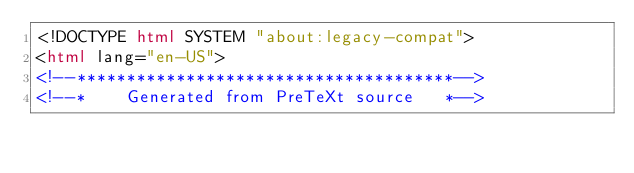<code> <loc_0><loc_0><loc_500><loc_500><_HTML_><!DOCTYPE html SYSTEM "about:legacy-compat">
<html lang="en-US">
<!--**************************************-->
<!--*    Generated from PreTeXt source   *--></code> 